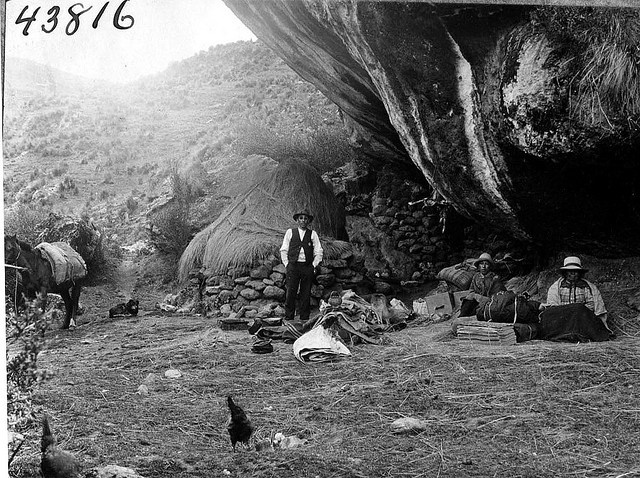Describe the objects in this image and their specific colors. I can see horse in darkgray, black, gray, and lightgray tones, people in darkgray, black, gray, and lightgray tones, people in darkgray, black, lightgray, and gray tones, people in darkgray, black, gray, and lightgray tones, and bird in darkgray, black, gray, and lightgray tones in this image. 